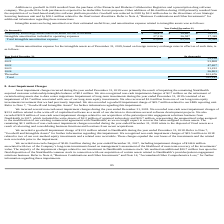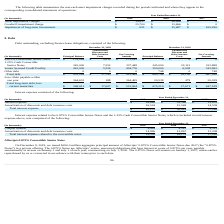According to Allscripts Healthcare Solutions's financial document, What caused the asset impairment charges in 2019? primarily the result of impairing the remaining NantHealth acquired customer relationship intangible balance of $8.1 million.. The document states: "urred during the year ended December 31, 2019 were primarily the result of impairing the remaining NantHealth acquired customer relationship intangibl..." Also, What was the non-cash impairment charge in 2019? According to the financial document, 2.7 million. The relevant text states: "e also recognized non-cash impairment charges of $2.7 million on the retirement of certain hosting assets due to data center migrations. Impairment of long-term..." Also, What is the Goodwill impairment charge in 2019? According to the financial document, $ 25,700 (in thousands). The relevant text states: "Goodwill impairment charge $ 25,700 $ 13,466 $ 0..." Also, can you calculate: What was the change in the asset impairment charges from 2018 to 2019? Based on the calculation: 10,837 - 58,166, the result is -47329 (in thousands). This is based on the information: "Asset impairment charges $ 10,837 $ 58,166 $ 0 Asset impairment charges $ 10,837 $ 58,166 $ 0..." The key data points involved are: 10,837, 58,166. Also, can you calculate: What is the average Goodwill impairment charge for 2017-2019? To answer this question, I need to perform calculations using the financial data. The calculation is: (25,700 + 13,466 + 0) / 3, which equals 13055.33 (in thousands). This is based on the information: "Goodwill impairment charge $ 25,700 $ 13,466 $ 0 Goodwill impairment charge $ 25,700 $ 13,466 $ 0 Goodwill impairment charge $ 25,700 $ 13,466 $ 0..." The key data points involved are: 13,466, 25,700. Also, can you calculate: What is the change in the Impairment of long-term investments between 2017 and 2018? Based on the calculation: 15,487 - 165,290, the result is -149803 (in thousands). This is based on the information: "Impairment of long-term investments $ 651 $ 15,487 $ 165,290 airment of long-term investments $ 651 $ 15,487 $ 165,290..." The key data points involved are: 15,487, 165,290. 